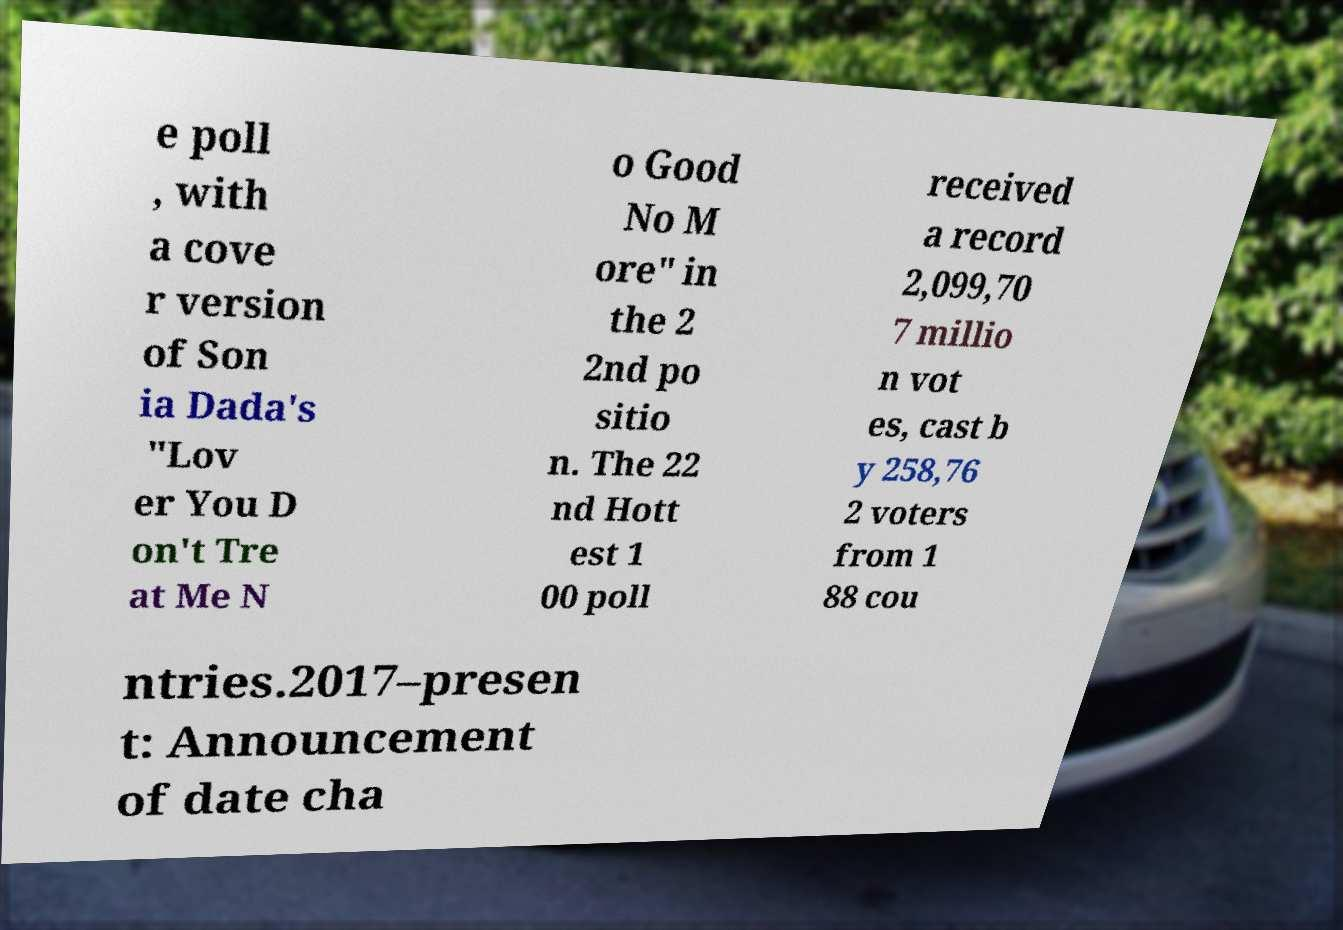What messages or text are displayed in this image? I need them in a readable, typed format. e poll , with a cove r version of Son ia Dada's "Lov er You D on't Tre at Me N o Good No M ore" in the 2 2nd po sitio n. The 22 nd Hott est 1 00 poll received a record 2,099,70 7 millio n vot es, cast b y 258,76 2 voters from 1 88 cou ntries.2017–presen t: Announcement of date cha 